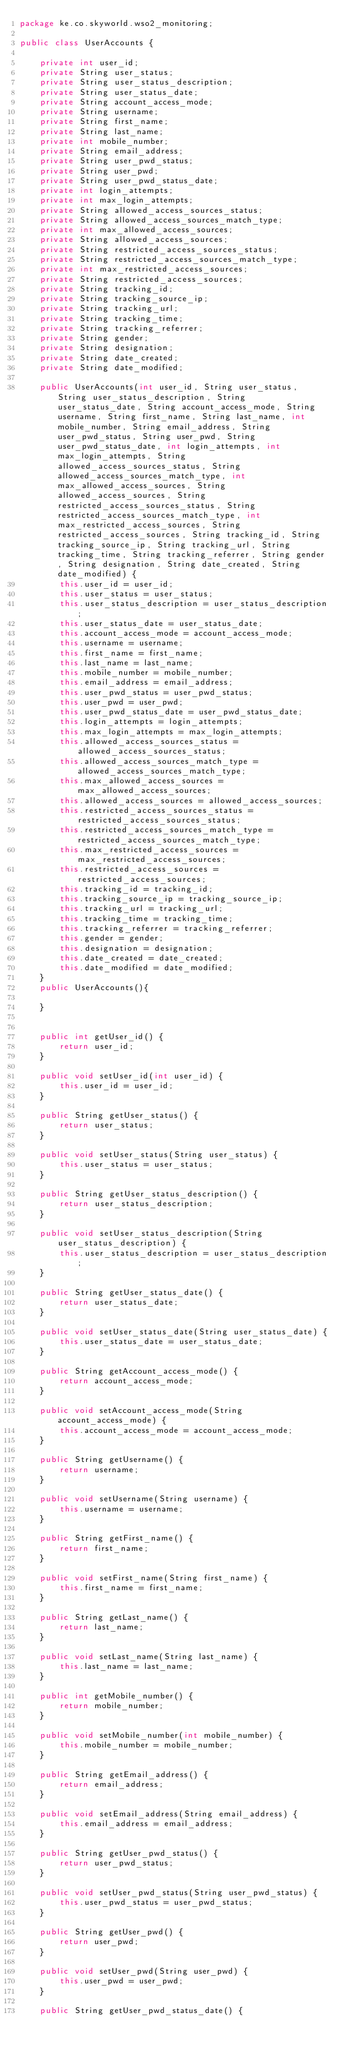<code> <loc_0><loc_0><loc_500><loc_500><_Java_>package ke.co.skyworld.wso2_monitoring;

public class UserAccounts {

    private int user_id;
    private String user_status;
    private String user_status_description;
    private String user_status_date;
    private String account_access_mode;
    private String username;
    private String first_name;
    private String last_name;
    private int mobile_number;
    private String email_address;
    private String user_pwd_status;
    private String user_pwd;
    private String user_pwd_status_date;
    private int login_attempts;
    private int max_login_attempts;
    private String allowed_access_sources_status;
    private String allowed_access_sources_match_type;
    private int max_allowed_access_sources;
    private String allowed_access_sources;
    private String restricted_access_sources_status;
    private String restricted_access_sources_match_type;
    private int max_restricted_access_sources;
    private String restricted_access_sources;
    private String tracking_id;
    private String tracking_source_ip;
    private String tracking_url;
    private String tracking_time;
    private String tracking_referrer;
    private String gender;
    private String designation;
    private String date_created;
    private String date_modified;

    public UserAccounts(int user_id, String user_status, String user_status_description, String user_status_date, String account_access_mode, String username, String first_name, String last_name, int mobile_number, String email_address, String user_pwd_status, String user_pwd, String user_pwd_status_date, int login_attempts, int max_login_attempts, String allowed_access_sources_status, String allowed_access_sources_match_type, int max_allowed_access_sources, String allowed_access_sources, String restricted_access_sources_status, String restricted_access_sources_match_type, int max_restricted_access_sources, String restricted_access_sources, String tracking_id, String tracking_source_ip, String tracking_url, String tracking_time, String tracking_referrer, String gender, String designation, String date_created, String date_modified) {
        this.user_id = user_id;
        this.user_status = user_status;
        this.user_status_description = user_status_description;
        this.user_status_date = user_status_date;
        this.account_access_mode = account_access_mode;
        this.username = username;
        this.first_name = first_name;
        this.last_name = last_name;
        this.mobile_number = mobile_number;
        this.email_address = email_address;
        this.user_pwd_status = user_pwd_status;
        this.user_pwd = user_pwd;
        this.user_pwd_status_date = user_pwd_status_date;
        this.login_attempts = login_attempts;
        this.max_login_attempts = max_login_attempts;
        this.allowed_access_sources_status = allowed_access_sources_status;
        this.allowed_access_sources_match_type = allowed_access_sources_match_type;
        this.max_allowed_access_sources = max_allowed_access_sources;
        this.allowed_access_sources = allowed_access_sources;
        this.restricted_access_sources_status = restricted_access_sources_status;
        this.restricted_access_sources_match_type = restricted_access_sources_match_type;
        this.max_restricted_access_sources = max_restricted_access_sources;
        this.restricted_access_sources = restricted_access_sources;
        this.tracking_id = tracking_id;
        this.tracking_source_ip = tracking_source_ip;
        this.tracking_url = tracking_url;
        this.tracking_time = tracking_time;
        this.tracking_referrer = tracking_referrer;
        this.gender = gender;
        this.designation = designation;
        this.date_created = date_created;
        this.date_modified = date_modified;
    }
    public UserAccounts(){

    }


    public int getUser_id() {
        return user_id;
    }

    public void setUser_id(int user_id) {
        this.user_id = user_id;
    }

    public String getUser_status() {
        return user_status;
    }

    public void setUser_status(String user_status) {
        this.user_status = user_status;
    }

    public String getUser_status_description() {
        return user_status_description;
    }

    public void setUser_status_description(String user_status_description) {
        this.user_status_description = user_status_description;
    }

    public String getUser_status_date() {
        return user_status_date;
    }

    public void setUser_status_date(String user_status_date) {
        this.user_status_date = user_status_date;
    }

    public String getAccount_access_mode() {
        return account_access_mode;
    }

    public void setAccount_access_mode(String account_access_mode) {
        this.account_access_mode = account_access_mode;
    }

    public String getUsername() {
        return username;
    }

    public void setUsername(String username) {
        this.username = username;
    }

    public String getFirst_name() {
        return first_name;
    }

    public void setFirst_name(String first_name) {
        this.first_name = first_name;
    }

    public String getLast_name() {
        return last_name;
    }

    public void setLast_name(String last_name) {
        this.last_name = last_name;
    }

    public int getMobile_number() {
        return mobile_number;
    }

    public void setMobile_number(int mobile_number) {
        this.mobile_number = mobile_number;
    }

    public String getEmail_address() {
        return email_address;
    }

    public void setEmail_address(String email_address) {
        this.email_address = email_address;
    }

    public String getUser_pwd_status() {
        return user_pwd_status;
    }

    public void setUser_pwd_status(String user_pwd_status) {
        this.user_pwd_status = user_pwd_status;
    }

    public String getUser_pwd() {
        return user_pwd;
    }

    public void setUser_pwd(String user_pwd) {
        this.user_pwd = user_pwd;
    }

    public String getUser_pwd_status_date() {</code> 